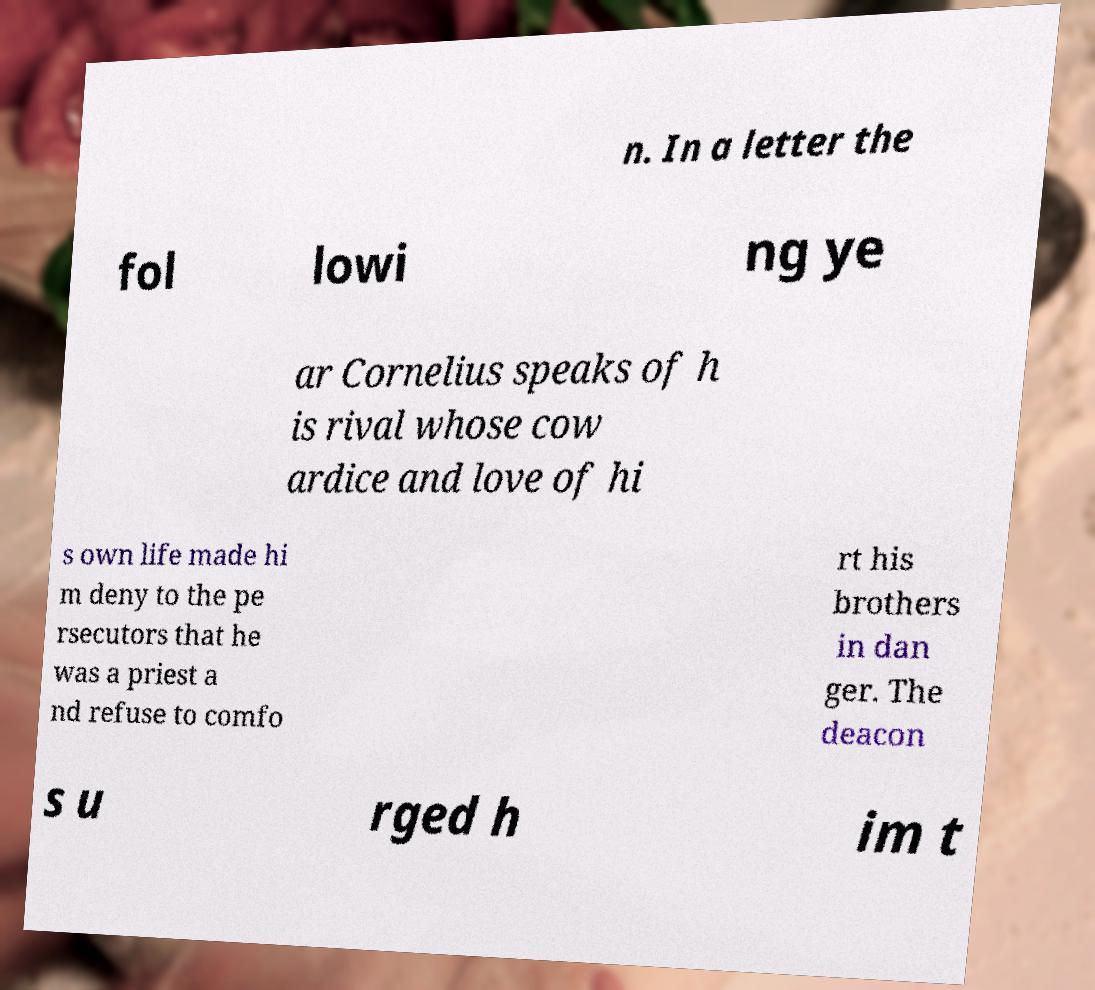Please read and relay the text visible in this image. What does it say? n. In a letter the fol lowi ng ye ar Cornelius speaks of h is rival whose cow ardice and love of hi s own life made hi m deny to the pe rsecutors that he was a priest a nd refuse to comfo rt his brothers in dan ger. The deacon s u rged h im t 